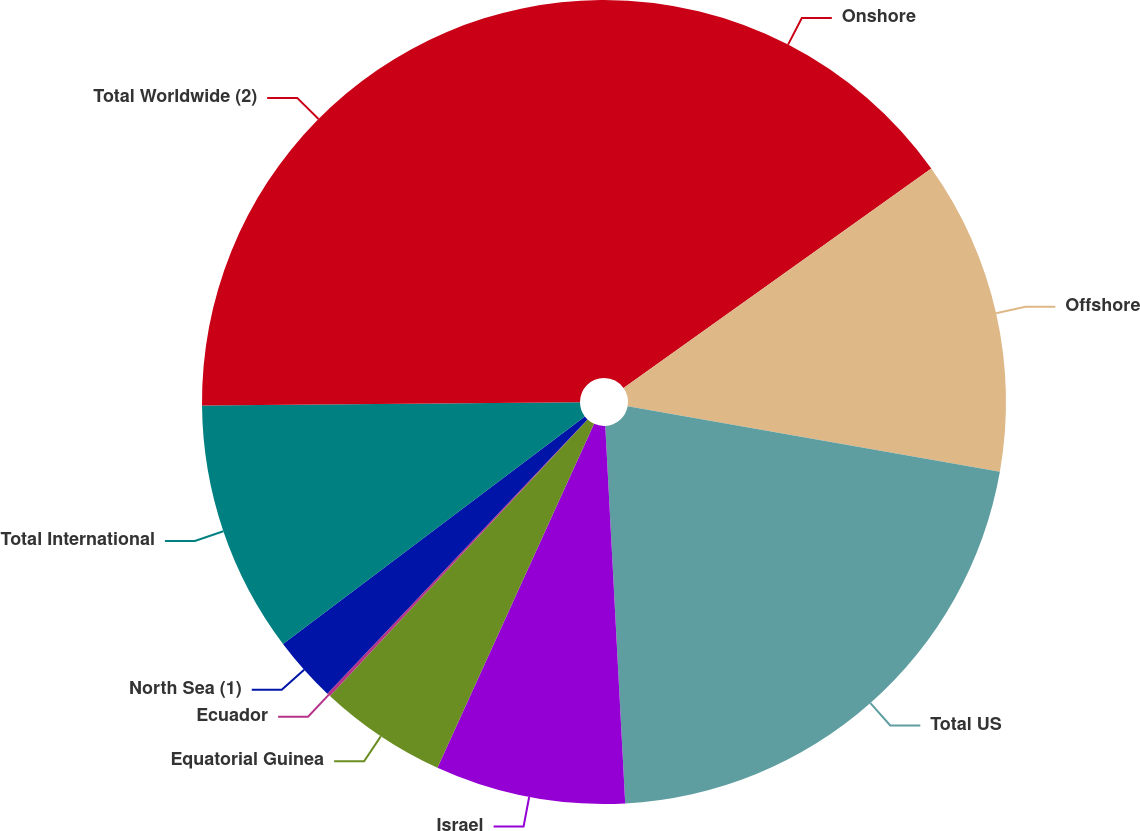Convert chart to OTSL. <chart><loc_0><loc_0><loc_500><loc_500><pie_chart><fcel>Onshore<fcel>Offshore<fcel>Total US<fcel>Israel<fcel>Equatorial Guinea<fcel>Ecuador<fcel>North Sea (1)<fcel>Total International<fcel>Total Worldwide (2)<nl><fcel>15.14%<fcel>12.64%<fcel>21.38%<fcel>7.64%<fcel>5.14%<fcel>0.14%<fcel>2.64%<fcel>10.14%<fcel>25.14%<nl></chart> 